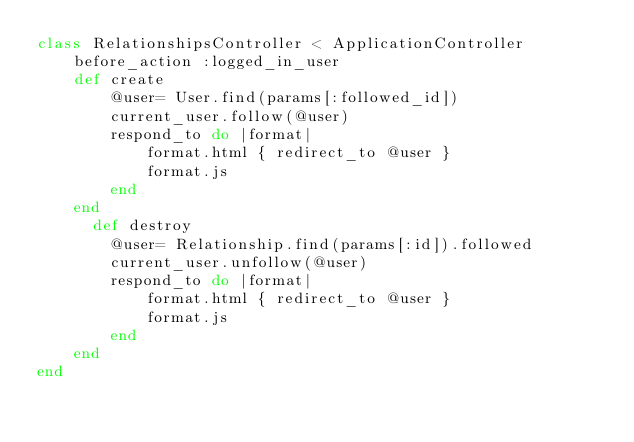Convert code to text. <code><loc_0><loc_0><loc_500><loc_500><_Ruby_>class RelationshipsController < ApplicationController
	before_action :logged_in_user
	def create
		@user= User.find(params[:followed_id])
		current_user.follow(@user)
		respond_to do |format|
      		format.html { redirect_to @user }
      		format.js
        end
    end
	  def destroy
		@user= Relationship.find(params[:id]).followed
		current_user.unfollow(@user)
		respond_to do |format|
      		format.html { redirect_to @user }
      		format.js
        end
    end
end
</code> 